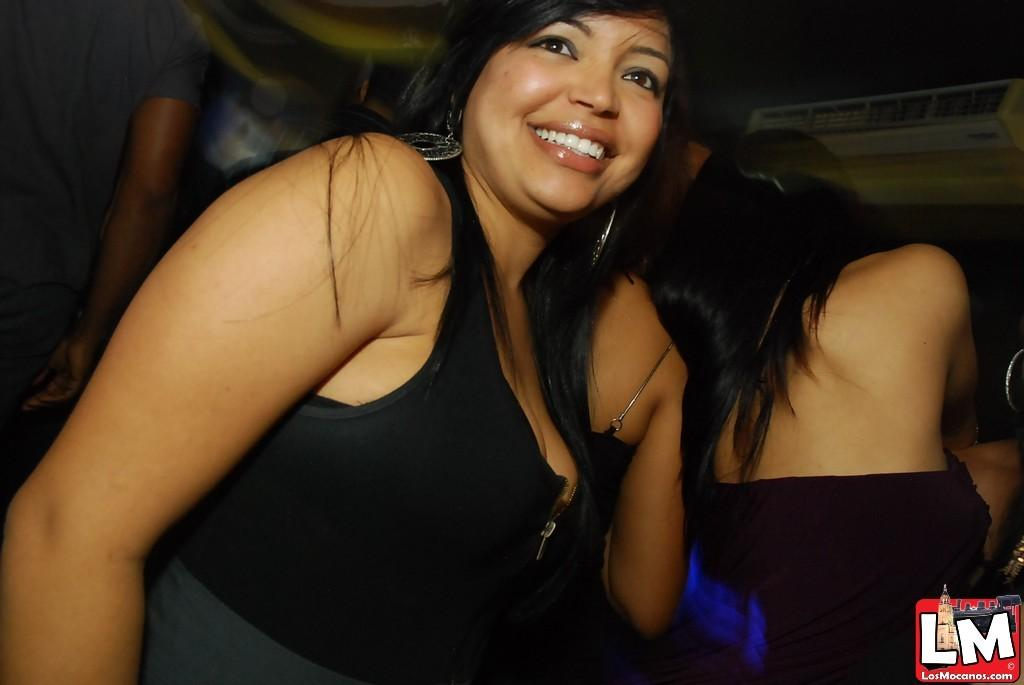Provide a one-sentence caption for the provided image. A woman in night club attire and a sticker that reads "LM Los Mocanos". 